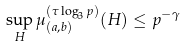Convert formula to latex. <formula><loc_0><loc_0><loc_500><loc_500>\sup _ { H } \mu _ { ( a , b ) } ^ { ( \tau \log _ { 3 } p ) } ( H ) \leq p ^ { - \gamma }</formula> 